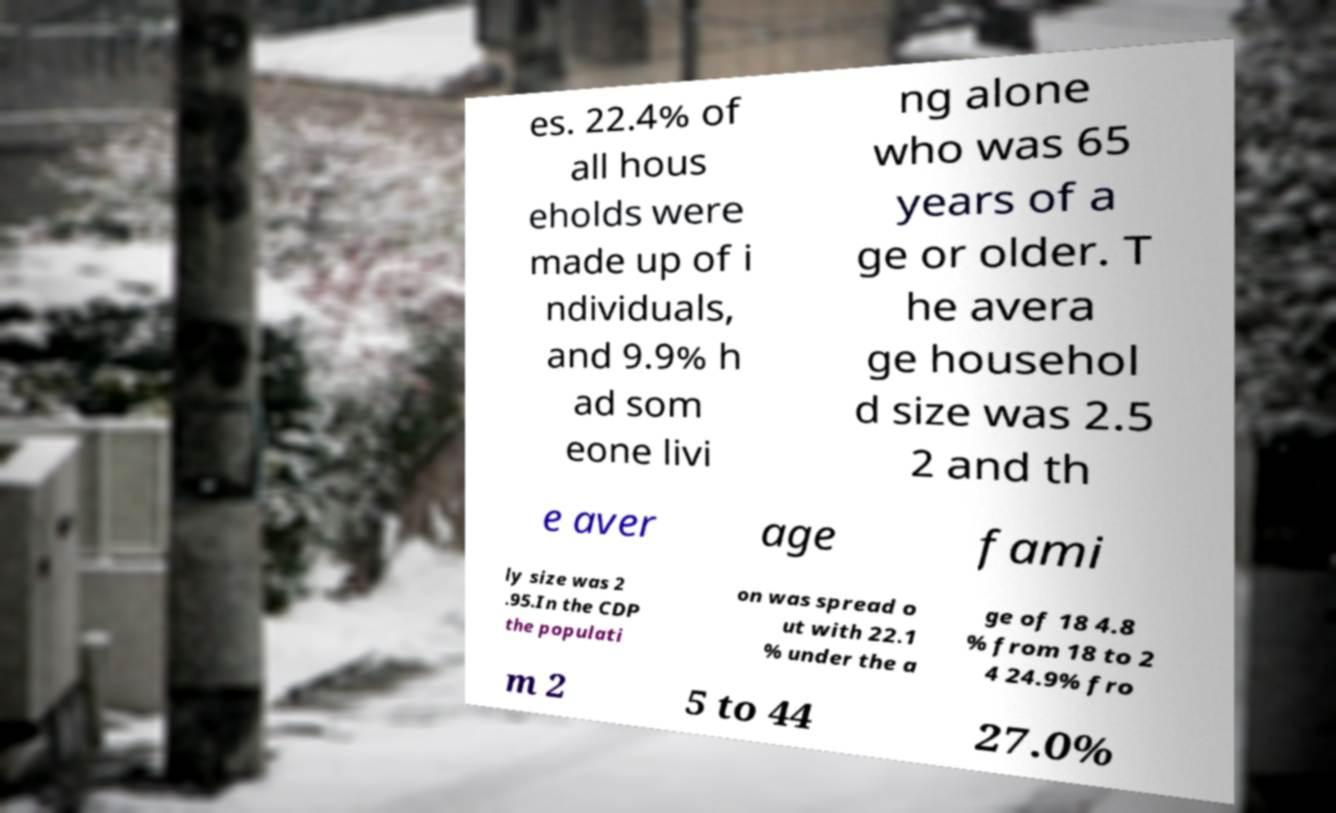What messages or text are displayed in this image? I need them in a readable, typed format. es. 22.4% of all hous eholds were made up of i ndividuals, and 9.9% h ad som eone livi ng alone who was 65 years of a ge or older. T he avera ge househol d size was 2.5 2 and th e aver age fami ly size was 2 .95.In the CDP the populati on was spread o ut with 22.1 % under the a ge of 18 4.8 % from 18 to 2 4 24.9% fro m 2 5 to 44 27.0% 